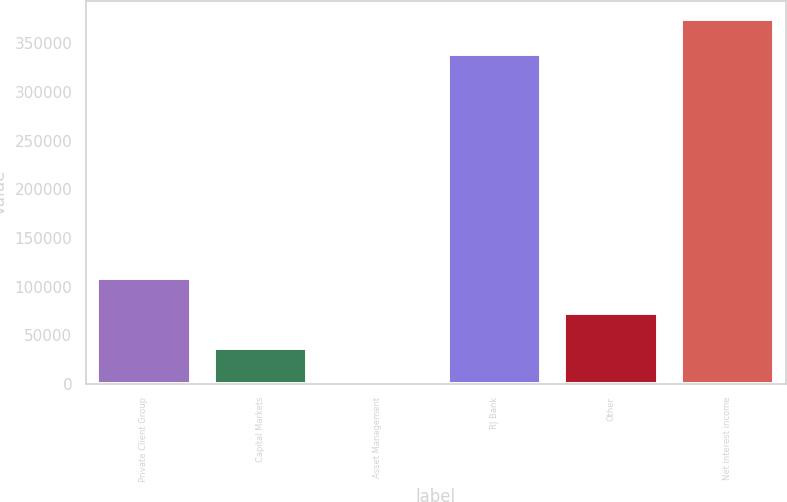Convert chart to OTSL. <chart><loc_0><loc_0><loc_500><loc_500><bar_chart><fcel>Private Client Group<fcel>Capital Markets<fcel>Asset Management<fcel>RJ Bank<fcel>Other<fcel>Net interest income<nl><fcel>109025<fcel>36395.7<fcel>81<fcel>338844<fcel>72710.4<fcel>375159<nl></chart> 